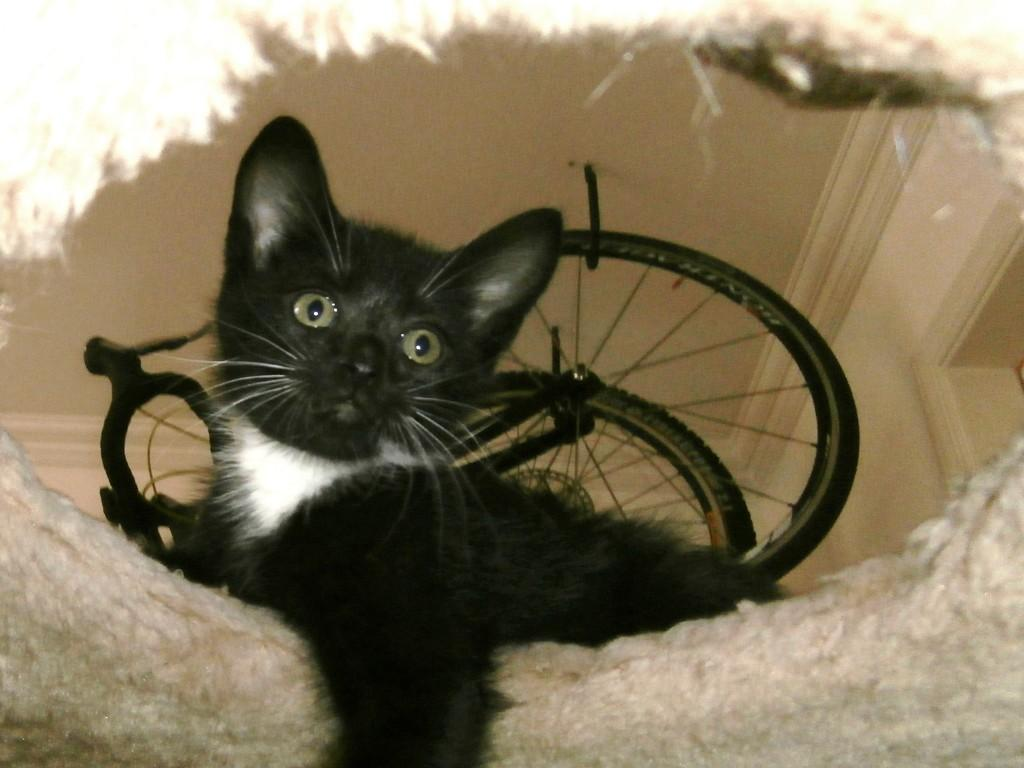What type of animal is in the image? There is a cat in the image. Can you describe the color of the cat? The cat is black. What can be seen in the middle of the image? There are wheels in the middle of the image. How many clocks are hanging on the wall in the image? There are no clocks visible in the image; it only features a black cat and wheels. What type of snake is coiled around the cat in the image? There is no snake present in the image; it only features a black cat and wheels. 